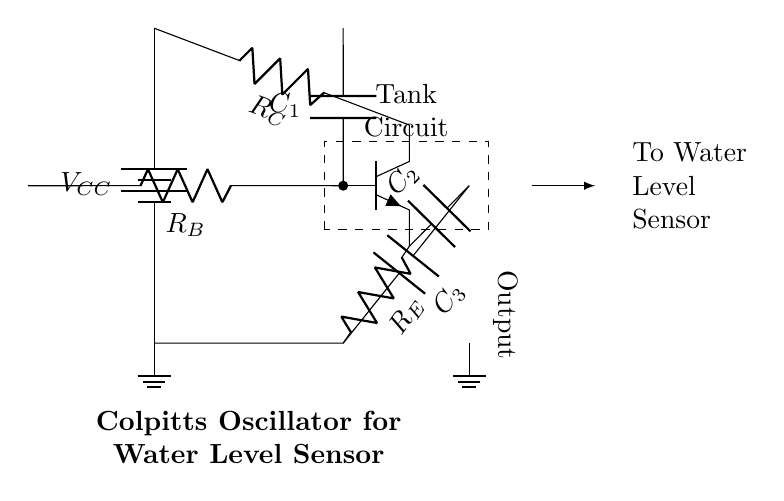What type of oscillator is this circuit? The circuit is identified as a Colpitts oscillator due to the presence of a transistor and the specific arrangement of capacitors and resistors that form the feedback network characteristic of this type of oscillator.
Answer: Colpitts What is the role of component R_B in this circuit? R_B serves as the biasing resistor that provides the necessary base current to the transistor, helping to establish the operating point and ensure proper functioning of the oscillator circuit.
Answer: Biasing How many capacitors are present in the circuit? The circuit diagram features three capacitors labeled C1, C2, and C3, which are integral to the oscillator's feedback mechanism and frequency determination.
Answer: Three What is the function of the output in this circuit? The output represents the generated sinusoidal signal that can be used for further processing, in this case, to control or monitor the water level sensor system, indicating the oscillation produced by the Colpitts oscillator.
Answer: Generated signal What is the voltage supply used in this oscillator circuit? The voltage supply in the circuit is denoted as V_CC, which provides the necessary power to the circuit, ensuring that the transistor functions correctly and the oscillations are sustained.
Answer: V_CC What effect do capacitors C2 and C3 have on the frequency of oscillation? Capacitors C2 and C3 form part of the feedback network and their values determine the oscillation frequency according to the Colpitts formula, influencing the timing of the output signal.
Answer: Frequency control 